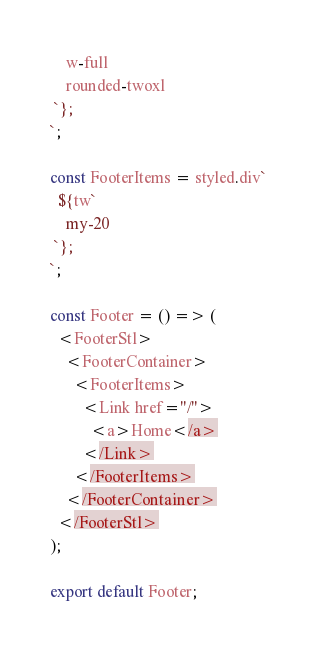Convert code to text. <code><loc_0><loc_0><loc_500><loc_500><_TypeScript_>    w-full
    rounded-twoxl
 `};
`;

const FooterItems = styled.div`
  ${tw`
    my-20
 `};
`;

const Footer = () => (
  <FooterStl>
    <FooterContainer>
      <FooterItems>
        <Link href="/">
          <a>Home</a>
        </Link>
      </FooterItems>
    </FooterContainer>
  </FooterStl>
);

export default Footer;
</code> 